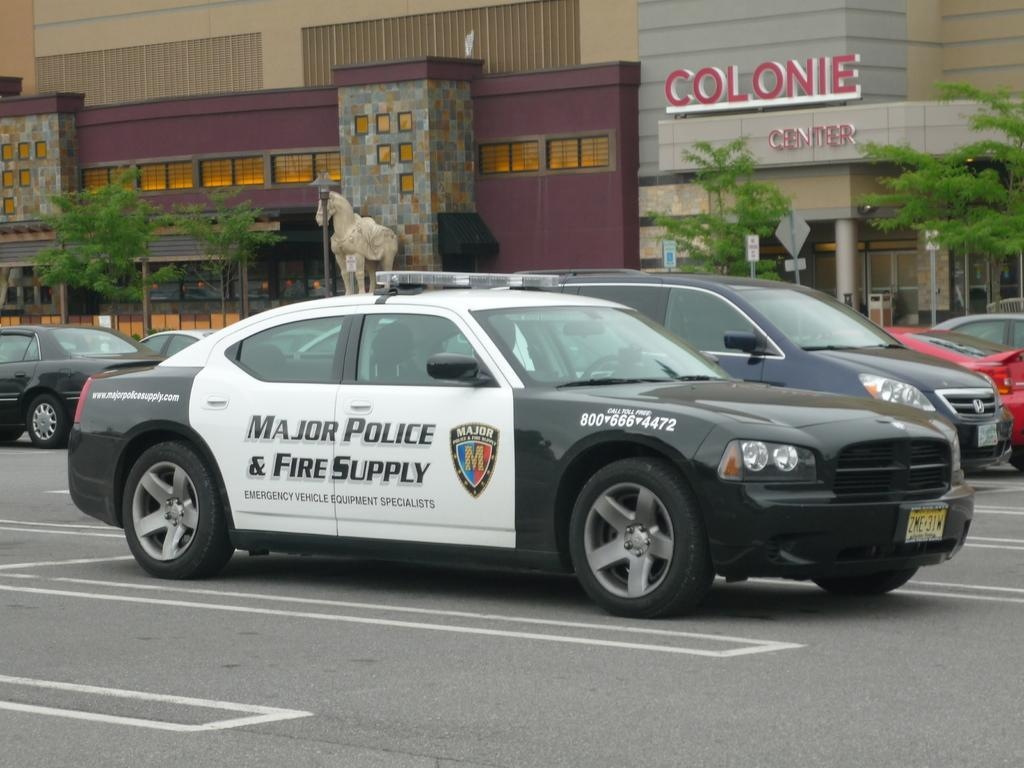What type of vehicles are in the front of the image? There are cars in the front of the image. What can be seen in the background of the image? There is a building in the background of the image. What objects are visible in the image that are not vehicles or buildings? There are boards and trees visible in the image. What is the main subject in the middle of the image? There is a statue in the middle of the image. How many rings are being exchanged in the image? There are no rings present in the image. What type of toys can be seen in the image? There are no toys present in the image. 